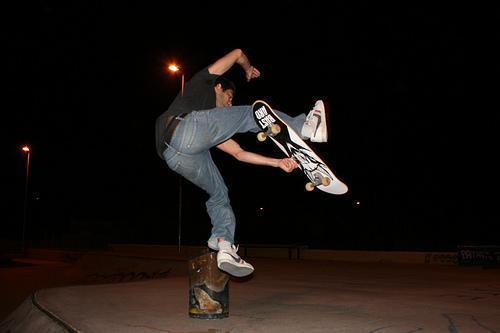How many wheels are on the board?
Give a very brief answer. 4. How many hands are holding the skateboard?
Give a very brief answer. 1. 